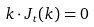<formula> <loc_0><loc_0><loc_500><loc_500>k \cdot J _ { t } ( k ) = 0</formula> 